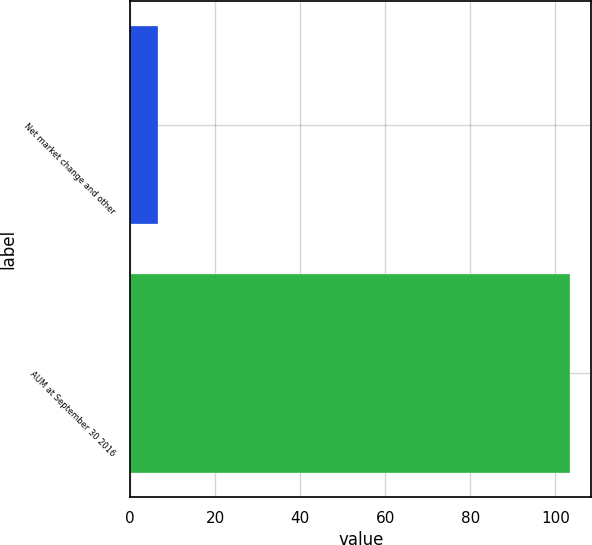Convert chart to OTSL. <chart><loc_0><loc_0><loc_500><loc_500><bar_chart><fcel>Net market change and other<fcel>AUM at September 30 2016<nl><fcel>6.5<fcel>103.3<nl></chart> 